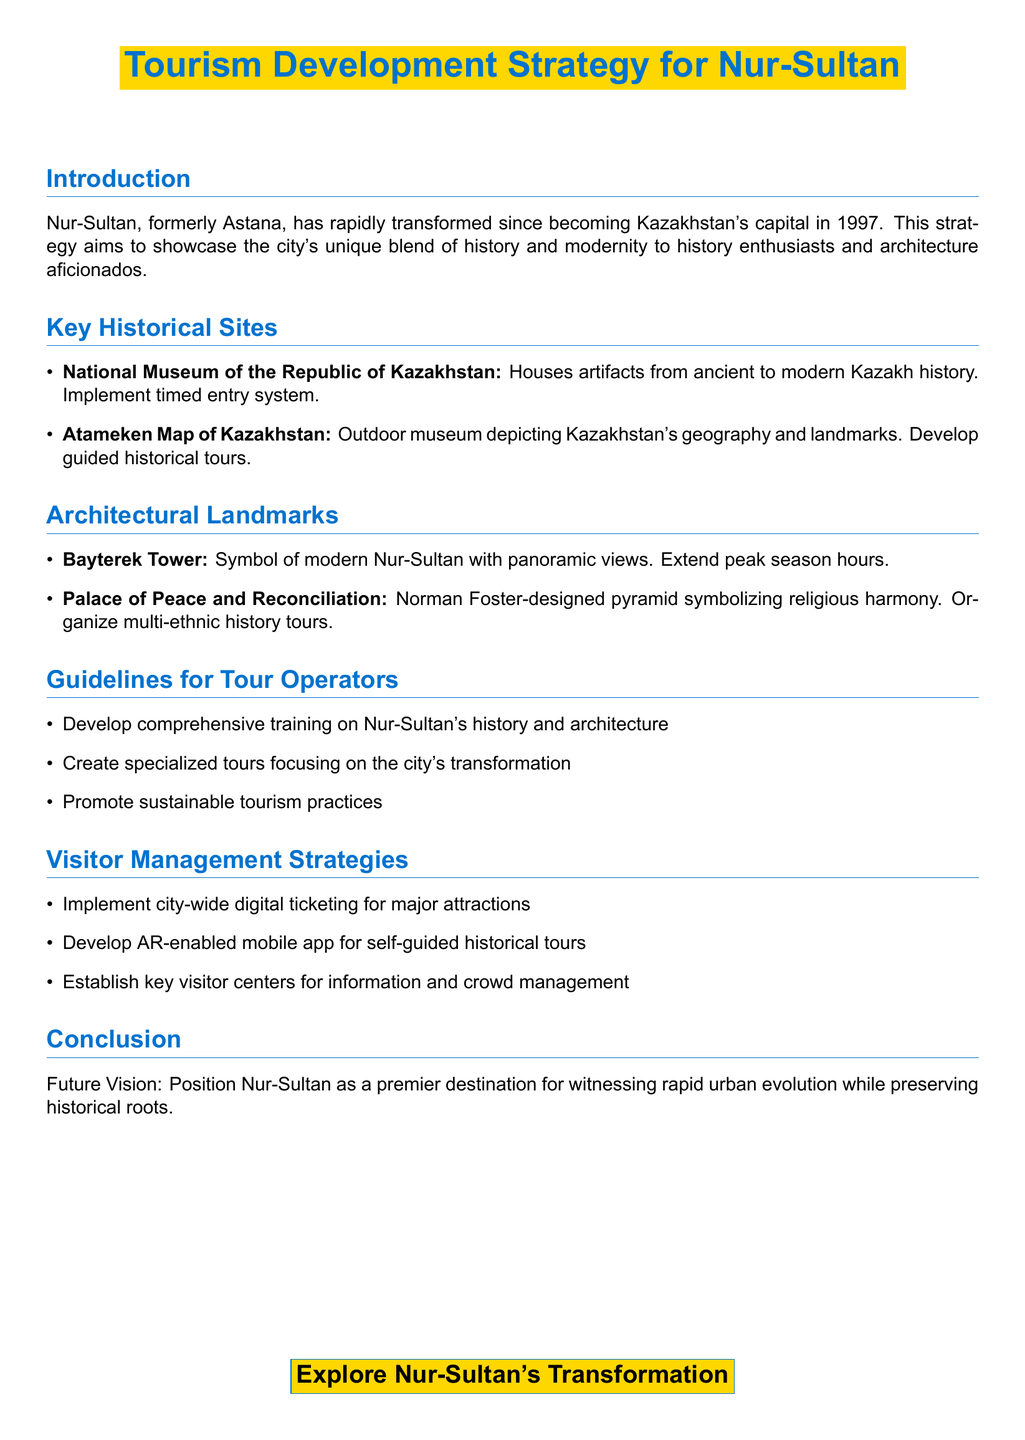What is the former name of Nur-Sultan? The document states that Nur-Sultan was formerly known as Astana.
Answer: Astana What year did Nur-Sultan become Kazakhstan's capital? The document mentions that Nur-Sultan became the capital in 1997.
Answer: 1997 Which museum houses artifacts from ancient to modern Kazakh history? The National Museum of the Republic of Kazakhstan is mentioned as housing these artifacts.
Answer: National Museum of the Republic of Kazakhstan Who designed the Palace of Peace and Reconciliation? The document specifies that the architect of the Palace is Norman Foster.
Answer: Norman Foster What type of system is implemented for the National Museum of the Republic of Kazakhstan? The document indicates that a timed entry system is implemented for this museum.
Answer: Timed entry system What is one of the guidelines for tour operators? The document outlines that developing comprehensive training on Nur-Sultan's history and architecture is a guideline.
Answer: Comprehensive training What is a visitor management strategy mentioned in the document? The document highlights the implementation of city-wide digital ticketing for major attractions.
Answer: City-wide digital ticketing What landmark symbolizes modern Nur-Sultan? The document states that Bayterek Tower is the symbol of modern Nur-Sultan.
Answer: Bayterek Tower What is the purpose of the AR-enabled mobile app mentioned? The document describes the app as developed for self-guided historical tours.
Answer: Self-guided historical tours 